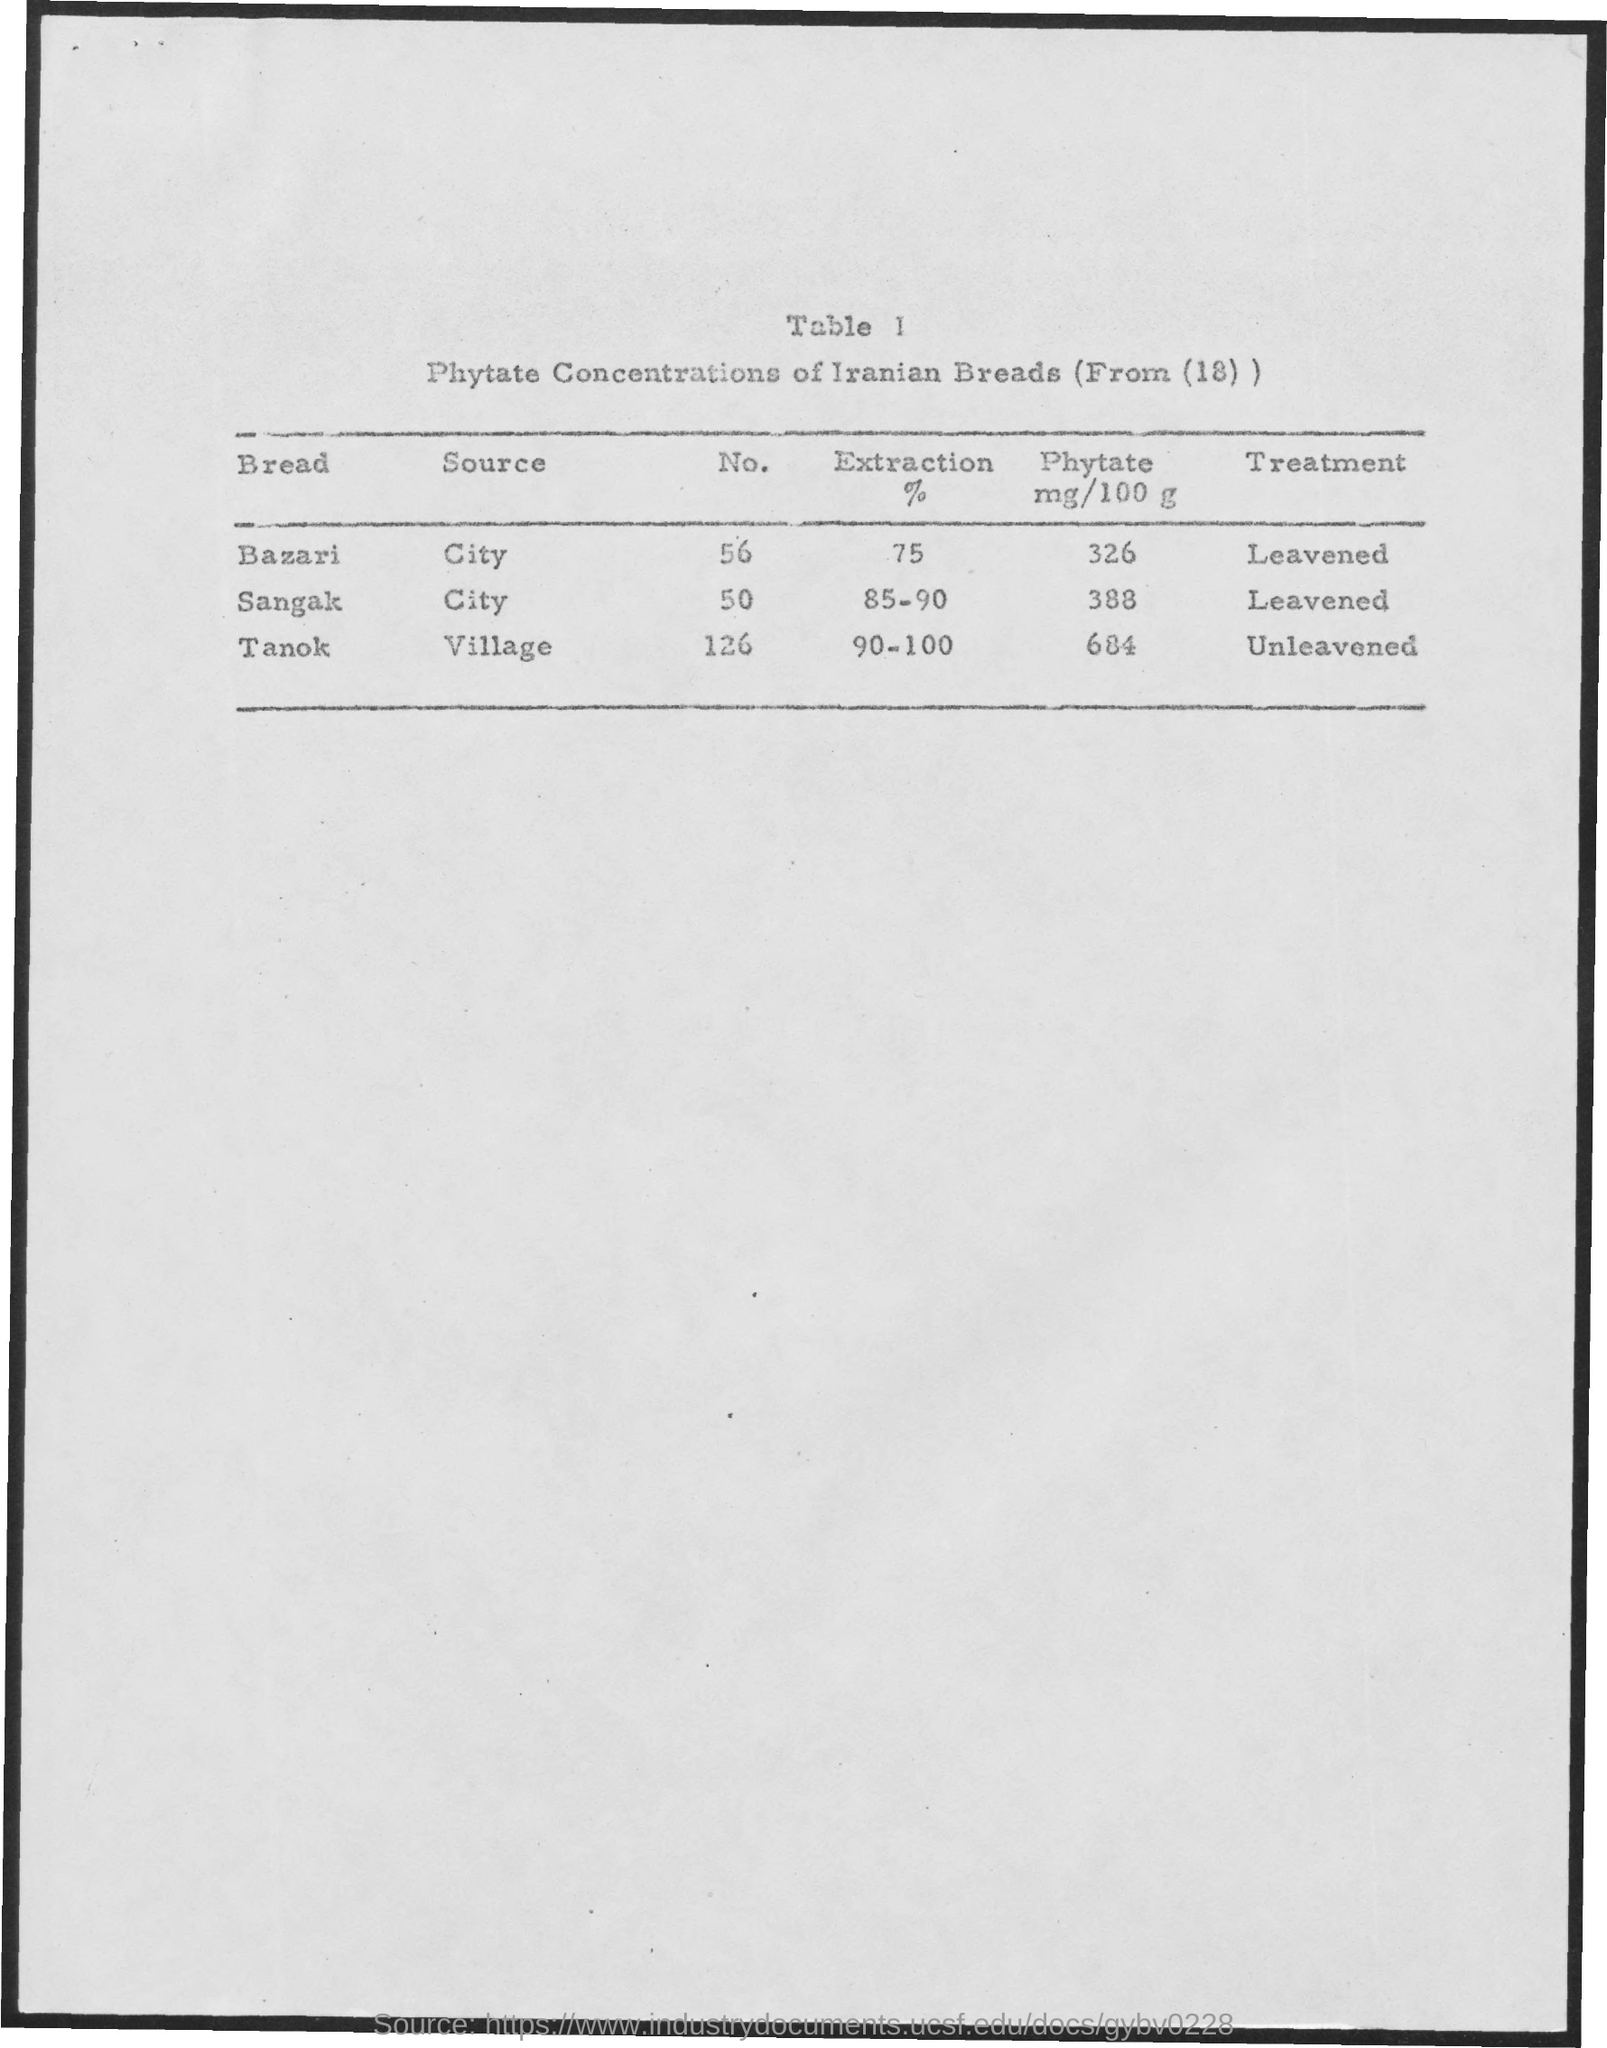List a handful of essential elements in this visual. The source of the term 'tanok' is the village. I am not familiar with "tanok." It is possible that it is a misspelling or a term that is not widely known or documented. If you could provide more information about what you are referring to, I may be able to assist you better. The treatment for sangak, which is a type of leavened bread, is to be made with flour, water, and yeast. The table number mentioned in the given page is [insert table number here]. 